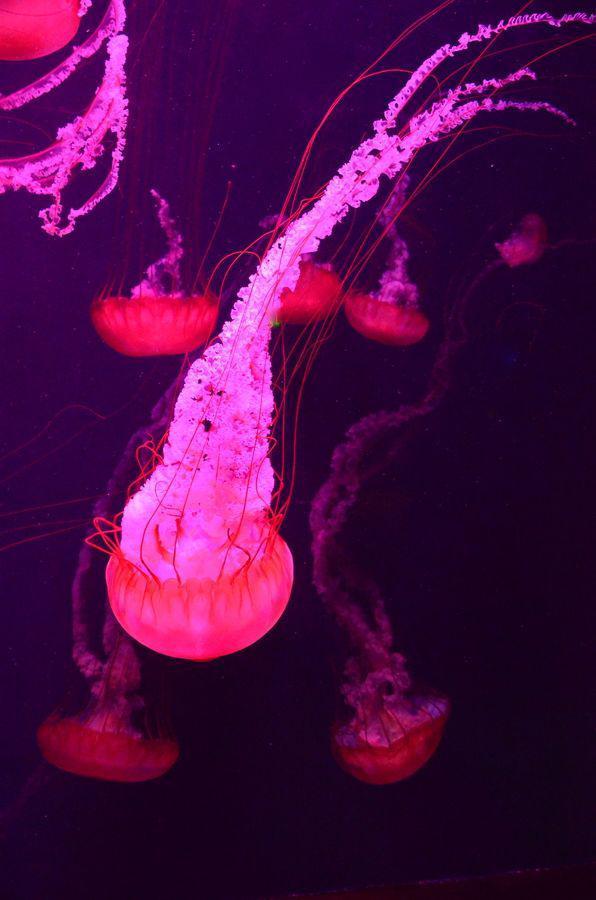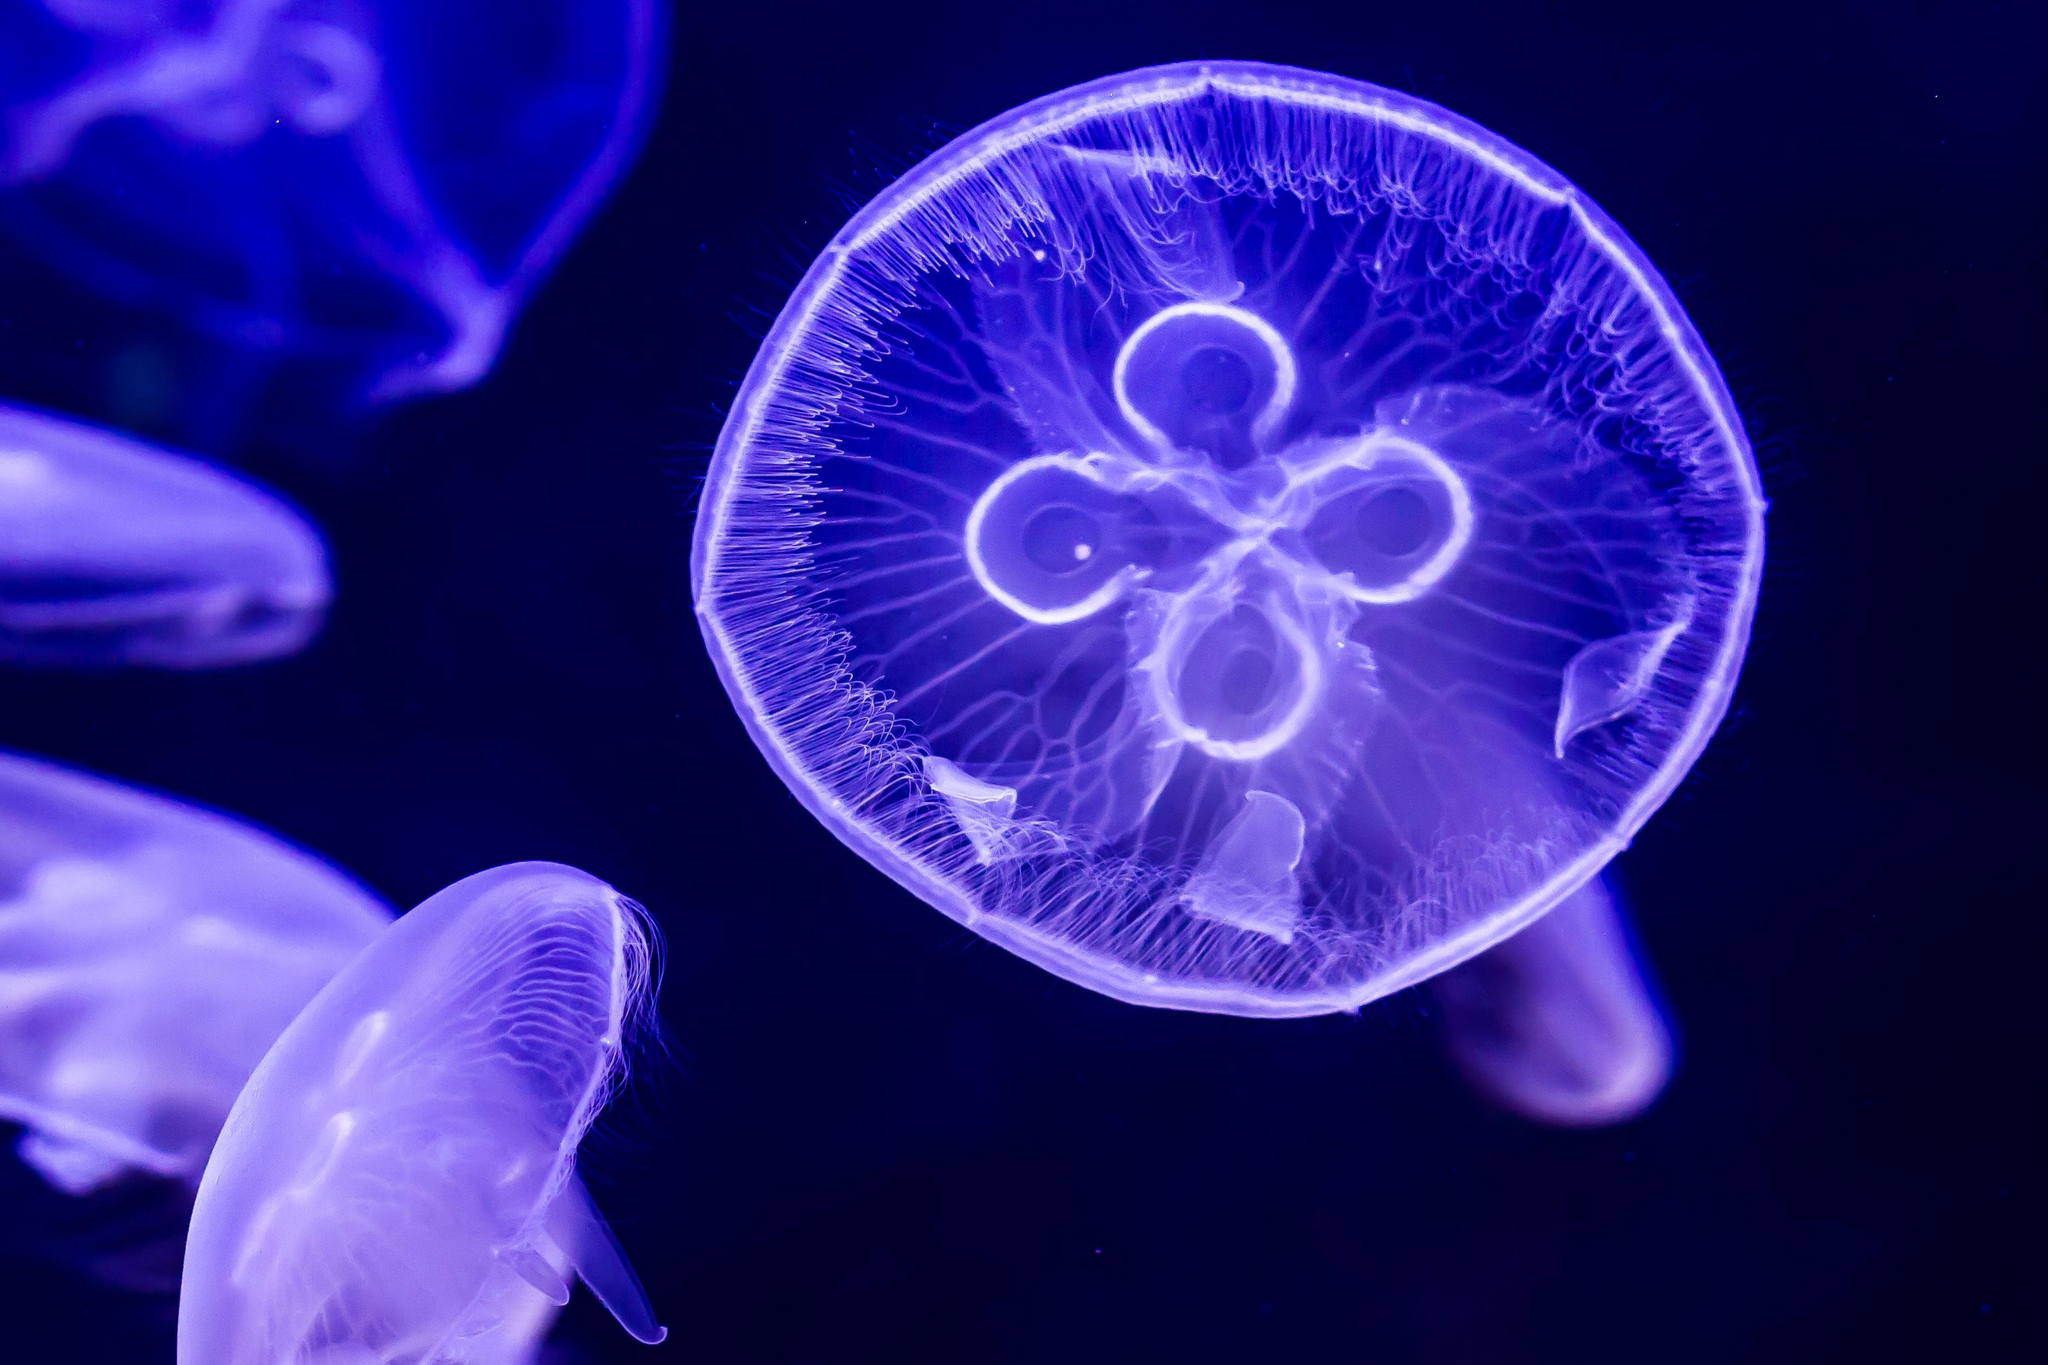The first image is the image on the left, the second image is the image on the right. Examine the images to the left and right. Is the description "An image shows multiple fluorescent pink jellyfish with tendrils trailing upward." accurate? Answer yes or no. Yes. The first image is the image on the left, the second image is the image on the right. For the images displayed, is the sentence "One of the images features exactly one jelly fish." factually correct? Answer yes or no. No. 